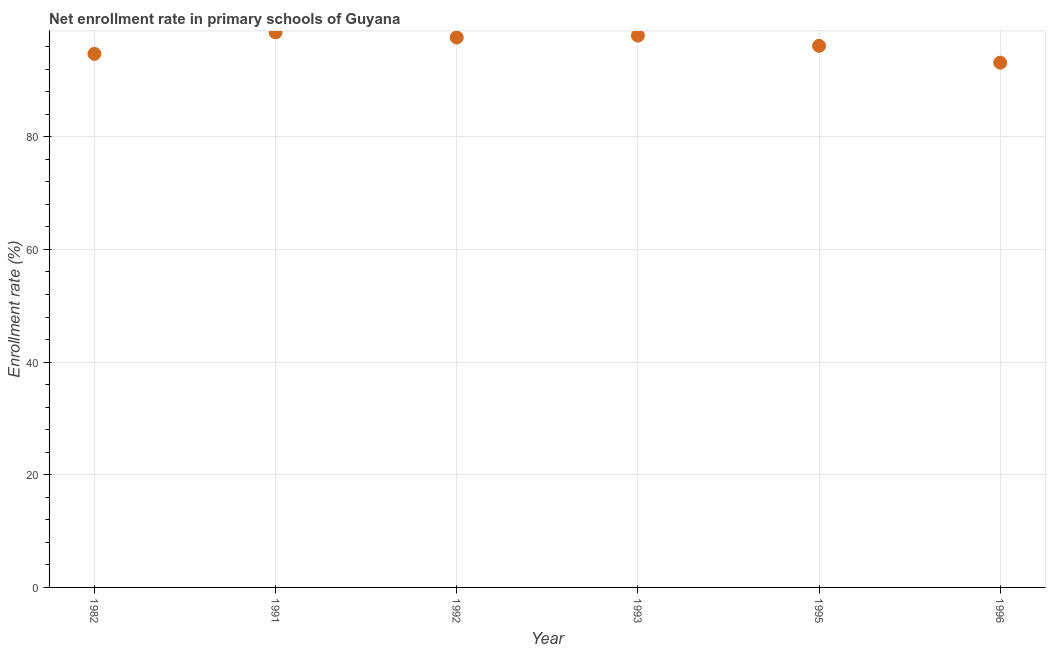What is the net enrollment rate in primary schools in 1982?
Your response must be concise. 94.73. Across all years, what is the maximum net enrollment rate in primary schools?
Offer a terse response. 98.54. Across all years, what is the minimum net enrollment rate in primary schools?
Provide a short and direct response. 93.15. In which year was the net enrollment rate in primary schools maximum?
Offer a very short reply. 1991. What is the sum of the net enrollment rate in primary schools?
Give a very brief answer. 578.15. What is the difference between the net enrollment rate in primary schools in 1991 and 1995?
Offer a very short reply. 2.39. What is the average net enrollment rate in primary schools per year?
Offer a terse response. 96.36. What is the median net enrollment rate in primary schools?
Offer a terse response. 96.89. What is the ratio of the net enrollment rate in primary schools in 1991 to that in 1992?
Keep it short and to the point. 1.01. What is the difference between the highest and the second highest net enrollment rate in primary schools?
Give a very brief answer. 0.58. What is the difference between the highest and the lowest net enrollment rate in primary schools?
Give a very brief answer. 5.39. In how many years, is the net enrollment rate in primary schools greater than the average net enrollment rate in primary schools taken over all years?
Your response must be concise. 3. Does the graph contain grids?
Make the answer very short. Yes. What is the title of the graph?
Your answer should be compact. Net enrollment rate in primary schools of Guyana. What is the label or title of the X-axis?
Offer a very short reply. Year. What is the label or title of the Y-axis?
Your answer should be compact. Enrollment rate (%). What is the Enrollment rate (%) in 1982?
Offer a very short reply. 94.73. What is the Enrollment rate (%) in 1991?
Give a very brief answer. 98.54. What is the Enrollment rate (%) in 1992?
Make the answer very short. 97.63. What is the Enrollment rate (%) in 1993?
Provide a succinct answer. 97.96. What is the Enrollment rate (%) in 1995?
Provide a short and direct response. 96.15. What is the Enrollment rate (%) in 1996?
Offer a very short reply. 93.15. What is the difference between the Enrollment rate (%) in 1982 and 1991?
Keep it short and to the point. -3.82. What is the difference between the Enrollment rate (%) in 1982 and 1992?
Keep it short and to the point. -2.9. What is the difference between the Enrollment rate (%) in 1982 and 1993?
Offer a very short reply. -3.23. What is the difference between the Enrollment rate (%) in 1982 and 1995?
Provide a succinct answer. -1.42. What is the difference between the Enrollment rate (%) in 1982 and 1996?
Your answer should be very brief. 1.57. What is the difference between the Enrollment rate (%) in 1991 and 1992?
Give a very brief answer. 0.91. What is the difference between the Enrollment rate (%) in 1991 and 1993?
Make the answer very short. 0.58. What is the difference between the Enrollment rate (%) in 1991 and 1995?
Your response must be concise. 2.39. What is the difference between the Enrollment rate (%) in 1991 and 1996?
Your response must be concise. 5.39. What is the difference between the Enrollment rate (%) in 1992 and 1993?
Your answer should be compact. -0.33. What is the difference between the Enrollment rate (%) in 1992 and 1995?
Your response must be concise. 1.48. What is the difference between the Enrollment rate (%) in 1992 and 1996?
Offer a terse response. 4.48. What is the difference between the Enrollment rate (%) in 1993 and 1995?
Provide a short and direct response. 1.81. What is the difference between the Enrollment rate (%) in 1993 and 1996?
Offer a very short reply. 4.8. What is the difference between the Enrollment rate (%) in 1995 and 1996?
Provide a short and direct response. 3. What is the ratio of the Enrollment rate (%) in 1982 to that in 1993?
Your response must be concise. 0.97. What is the ratio of the Enrollment rate (%) in 1982 to that in 1996?
Your answer should be very brief. 1.02. What is the ratio of the Enrollment rate (%) in 1991 to that in 1993?
Give a very brief answer. 1.01. What is the ratio of the Enrollment rate (%) in 1991 to that in 1995?
Your answer should be compact. 1.02. What is the ratio of the Enrollment rate (%) in 1991 to that in 1996?
Give a very brief answer. 1.06. What is the ratio of the Enrollment rate (%) in 1992 to that in 1993?
Your response must be concise. 1. What is the ratio of the Enrollment rate (%) in 1992 to that in 1995?
Your response must be concise. 1.01. What is the ratio of the Enrollment rate (%) in 1992 to that in 1996?
Ensure brevity in your answer.  1.05. What is the ratio of the Enrollment rate (%) in 1993 to that in 1996?
Keep it short and to the point. 1.05. What is the ratio of the Enrollment rate (%) in 1995 to that in 1996?
Make the answer very short. 1.03. 